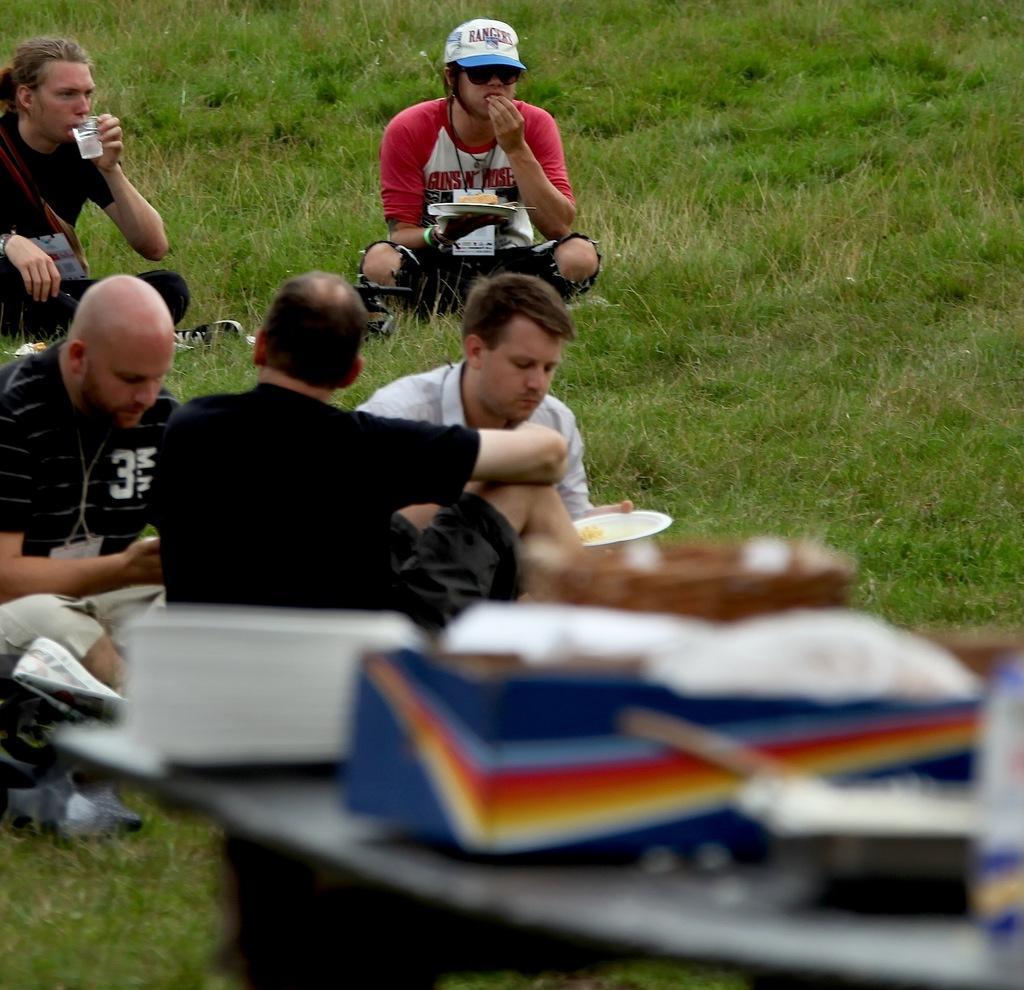Can you describe this image briefly? In the image we can see there are people sitting wearing clothes and one is wearing goggles and cap. We can see grass and a person is holding a glass. 